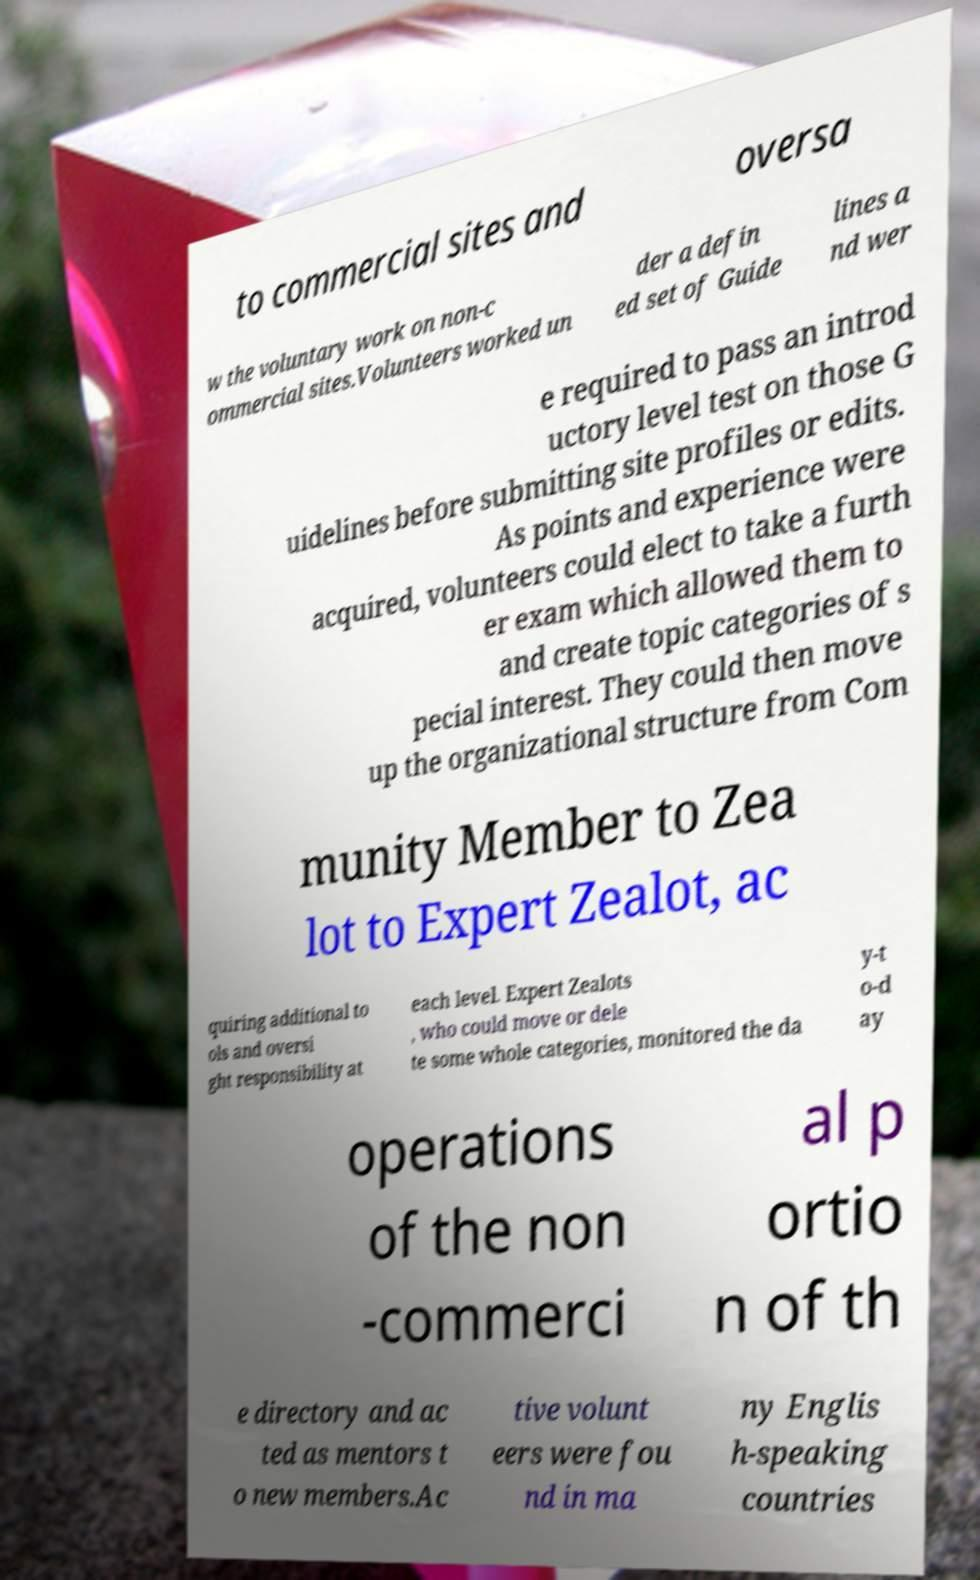I need the written content from this picture converted into text. Can you do that? to commercial sites and oversa w the voluntary work on non-c ommercial sites.Volunteers worked un der a defin ed set of Guide lines a nd wer e required to pass an introd uctory level test on those G uidelines before submitting site profiles or edits. As points and experience were acquired, volunteers could elect to take a furth er exam which allowed them to and create topic categories of s pecial interest. They could then move up the organizational structure from Com munity Member to Zea lot to Expert Zealot, ac quiring additional to ols and oversi ght responsibility at each level. Expert Zealots , who could move or dele te some whole categories, monitored the da y-t o-d ay operations of the non -commerci al p ortio n of th e directory and ac ted as mentors t o new members.Ac tive volunt eers were fou nd in ma ny Englis h-speaking countries 